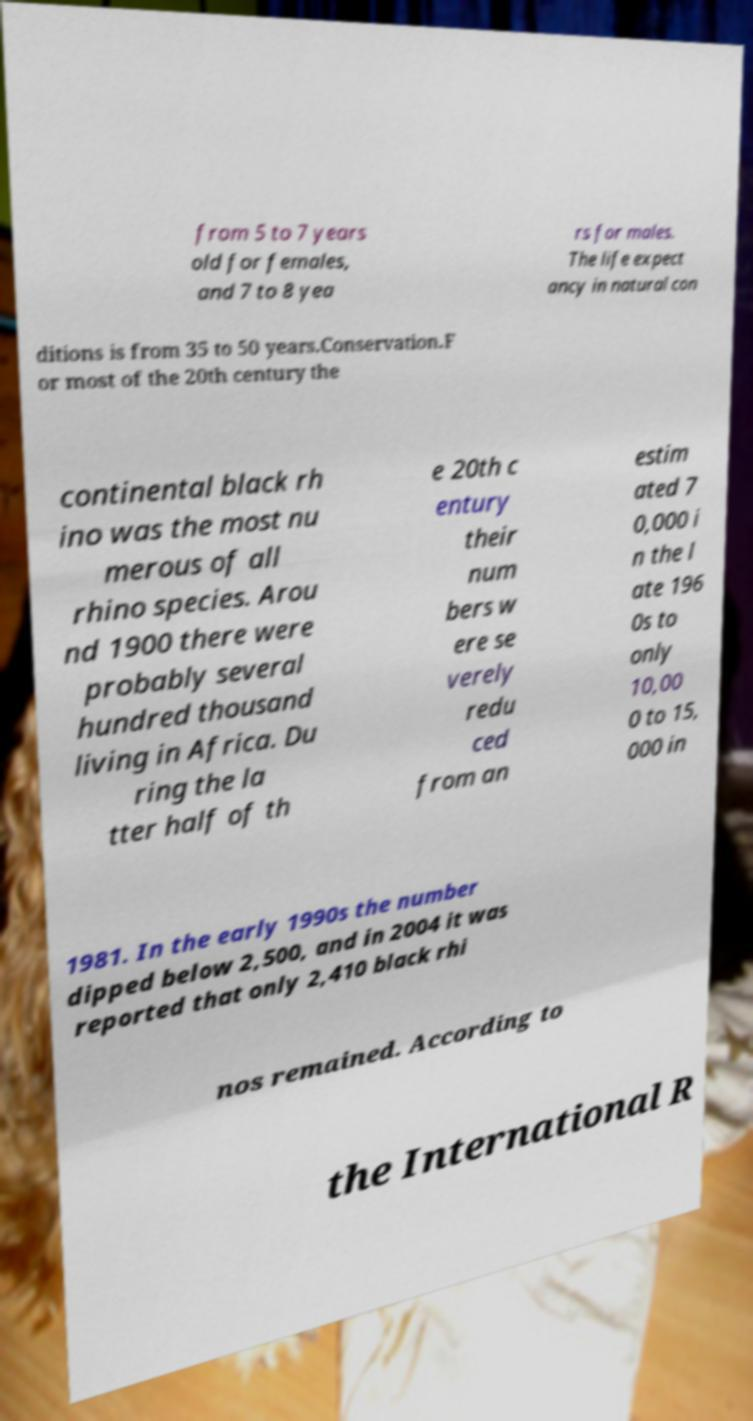Can you read and provide the text displayed in the image?This photo seems to have some interesting text. Can you extract and type it out for me? from 5 to 7 years old for females, and 7 to 8 yea rs for males. The life expect ancy in natural con ditions is from 35 to 50 years.Conservation.F or most of the 20th century the continental black rh ino was the most nu merous of all rhino species. Arou nd 1900 there were probably several hundred thousand living in Africa. Du ring the la tter half of th e 20th c entury their num bers w ere se verely redu ced from an estim ated 7 0,000 i n the l ate 196 0s to only 10,00 0 to 15, 000 in 1981. In the early 1990s the number dipped below 2,500, and in 2004 it was reported that only 2,410 black rhi nos remained. According to the International R 